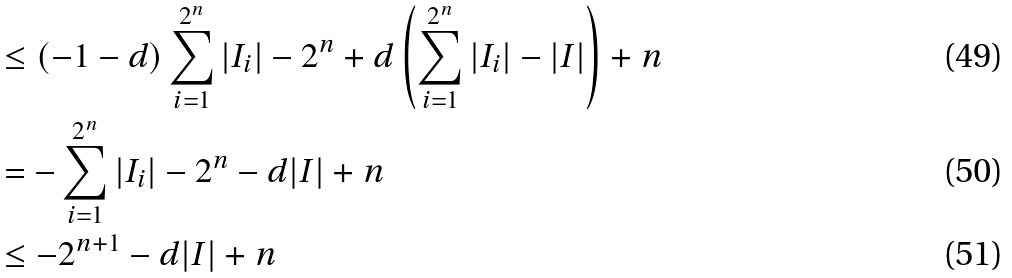Convert formula to latex. <formula><loc_0><loc_0><loc_500><loc_500>& \leq ( - 1 - d ) \sum _ { i = 1 } ^ { 2 ^ { n } } | I _ { i } | - 2 ^ { n } + d \left ( \sum _ { i = 1 } ^ { 2 ^ { n } } | I _ { i } | - | I | \right ) + n \\ & = - \sum _ { i = 1 } ^ { 2 ^ { n } } | I _ { i } | - 2 ^ { n } - d | I | + n \\ & \leq - 2 ^ { n + 1 } - d | I | + n</formula> 